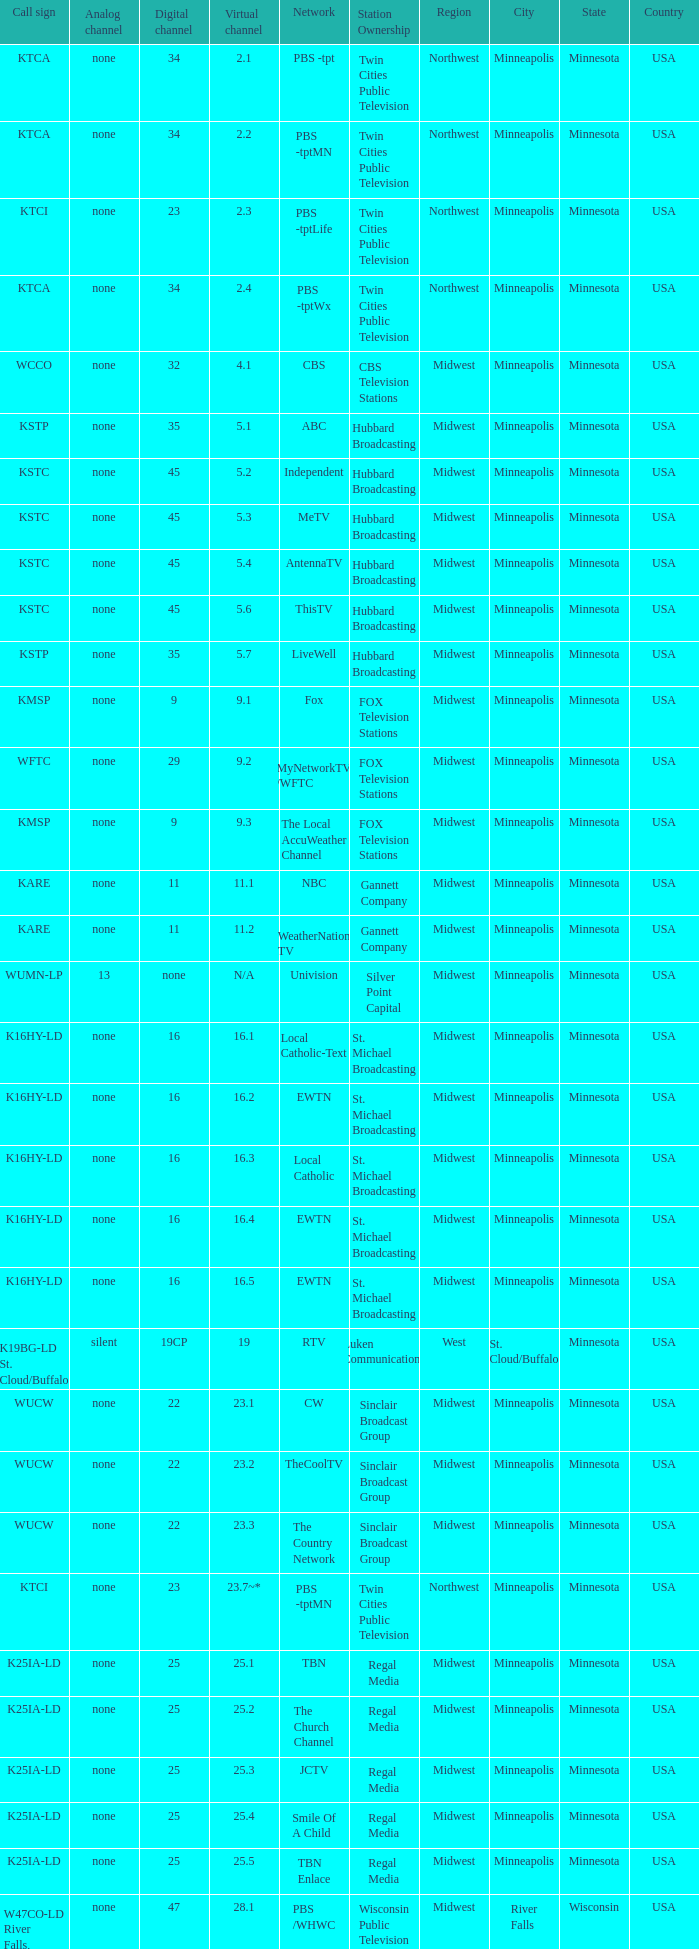Virtual channel of 16.5 has what call sign? K16HY-LD. 